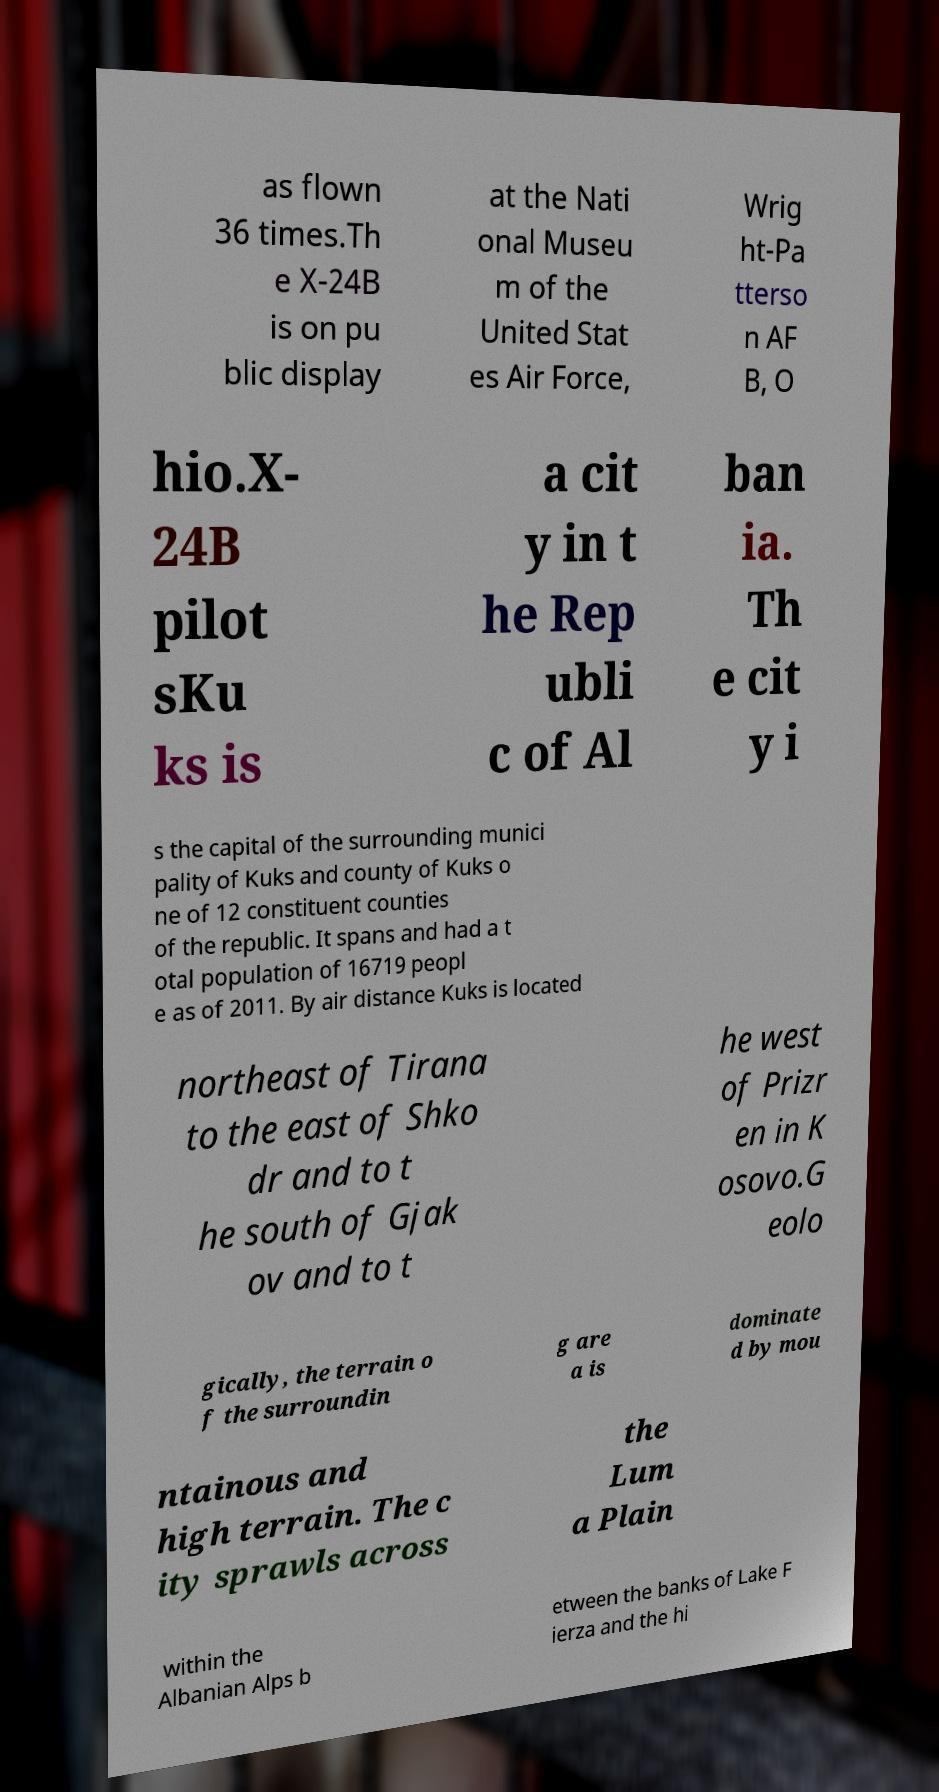There's text embedded in this image that I need extracted. Can you transcribe it verbatim? as flown 36 times.Th e X-24B is on pu blic display at the Nati onal Museu m of the United Stat es Air Force, Wrig ht-Pa tterso n AF B, O hio.X- 24B pilot sKu ks is a cit y in t he Rep ubli c of Al ban ia. Th e cit y i s the capital of the surrounding munici pality of Kuks and county of Kuks o ne of 12 constituent counties of the republic. It spans and had a t otal population of 16719 peopl e as of 2011. By air distance Kuks is located northeast of Tirana to the east of Shko dr and to t he south of Gjak ov and to t he west of Prizr en in K osovo.G eolo gically, the terrain o f the surroundin g are a is dominate d by mou ntainous and high terrain. The c ity sprawls across the Lum a Plain within the Albanian Alps b etween the banks of Lake F ierza and the hi 